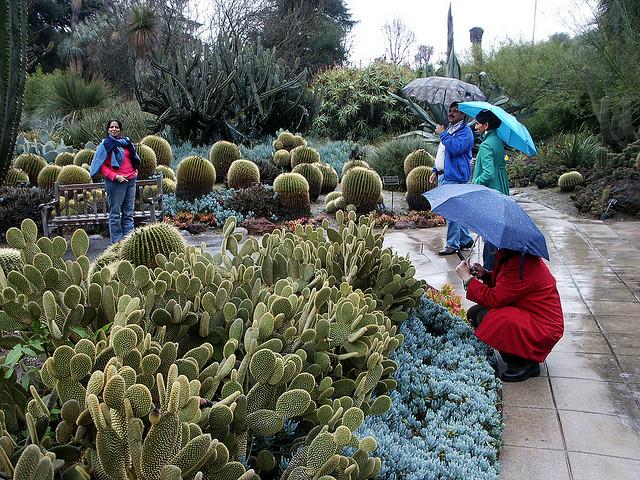What are the people doing?
Quick response, please. Standing. Are they in a botanical garden?
Answer briefly. Yes. Is it raining?
Be succinct. Yes. Can the plants in the center be held in your hands?
Be succinct. No. 